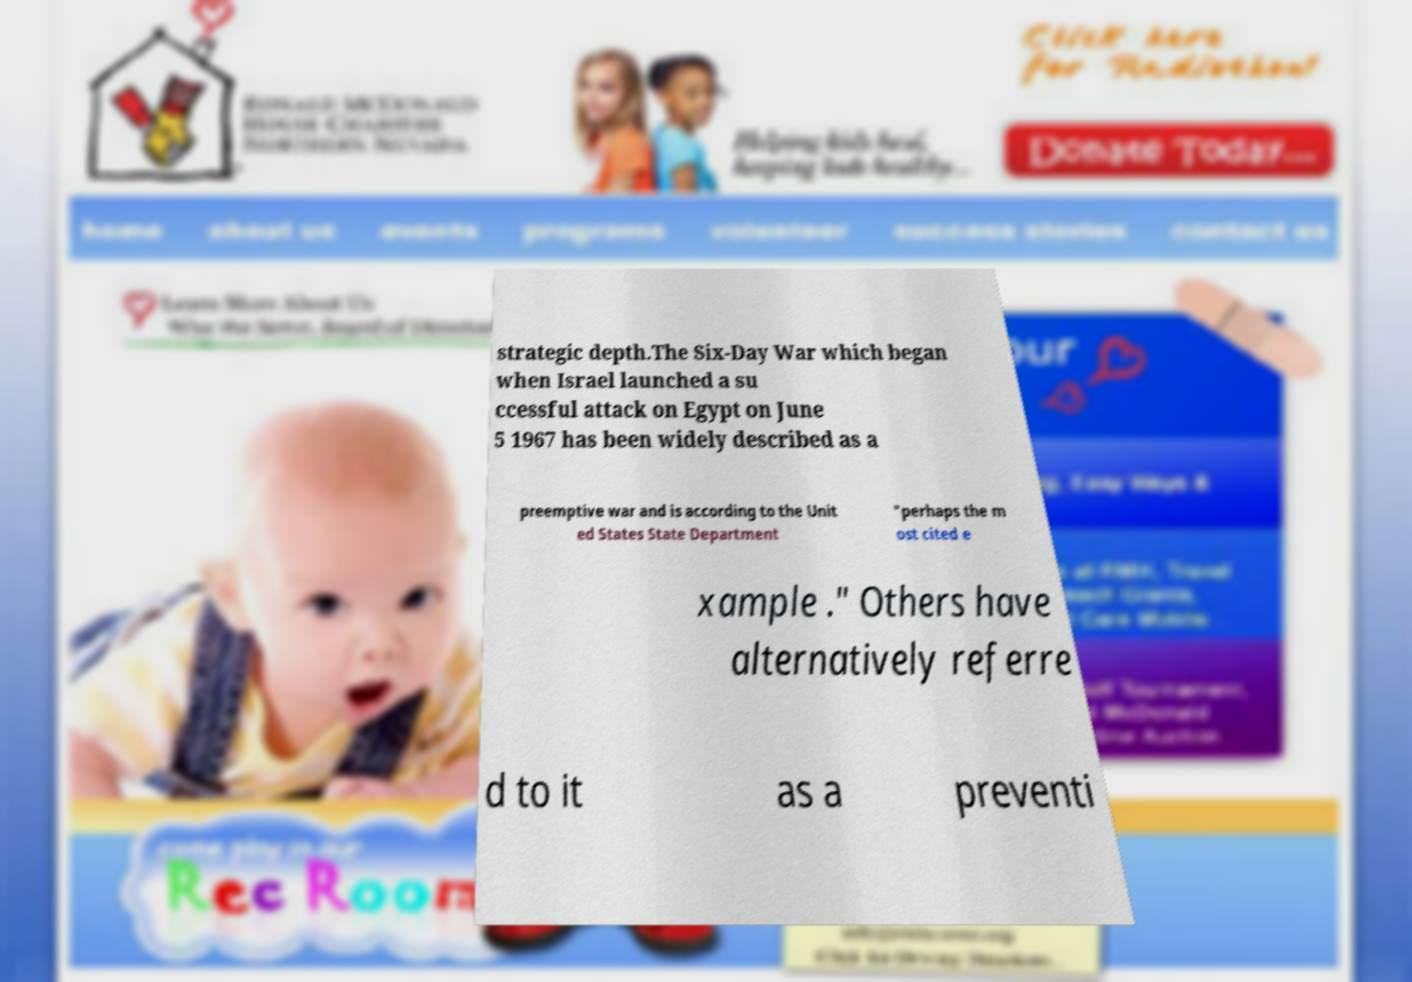I need the written content from this picture converted into text. Can you do that? strategic depth.The Six-Day War which began when Israel launched a su ccessful attack on Egypt on June 5 1967 has been widely described as a preemptive war and is according to the Unit ed States State Department "perhaps the m ost cited e xample ." Others have alternatively referre d to it as a preventi 